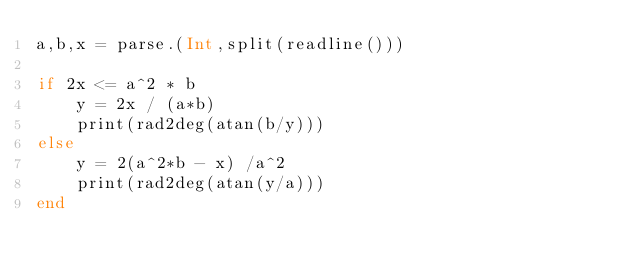<code> <loc_0><loc_0><loc_500><loc_500><_Julia_>a,b,x = parse.(Int,split(readline()))

if 2x <= a^2 * b
    y = 2x / (a*b)
    print(rad2deg(atan(b/y)))
else
    y = 2(a^2*b - x) /a^2
    print(rad2deg(atan(y/a)))
end</code> 